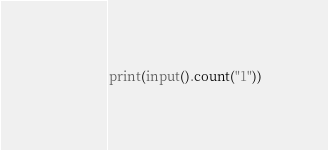<code> <loc_0><loc_0><loc_500><loc_500><_Python_>print(input().count("1"))</code> 